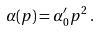<formula> <loc_0><loc_0><loc_500><loc_500>\alpha ( p ) = \alpha _ { 0 } ^ { \prime } p ^ { 2 } \, .</formula> 